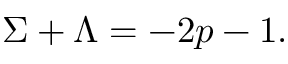<formula> <loc_0><loc_0><loc_500><loc_500>\Sigma + \Lambda = - 2 p - 1 .</formula> 